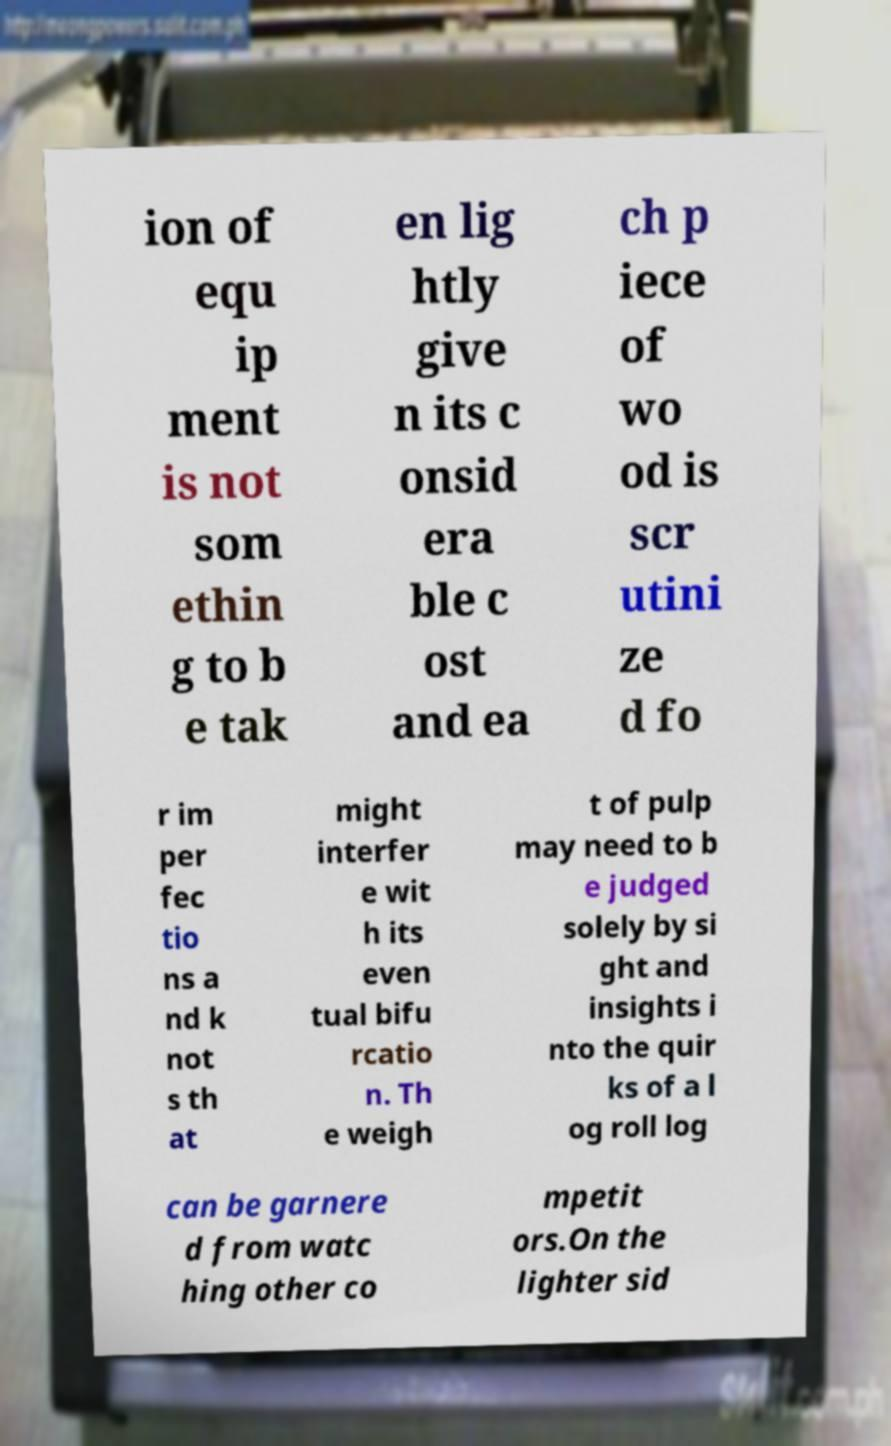For documentation purposes, I need the text within this image transcribed. Could you provide that? ion of equ ip ment is not som ethin g to b e tak en lig htly give n its c onsid era ble c ost and ea ch p iece of wo od is scr utini ze d fo r im per fec tio ns a nd k not s th at might interfer e wit h its even tual bifu rcatio n. Th e weigh t of pulp may need to b e judged solely by si ght and insights i nto the quir ks of a l og roll log can be garnere d from watc hing other co mpetit ors.On the lighter sid 